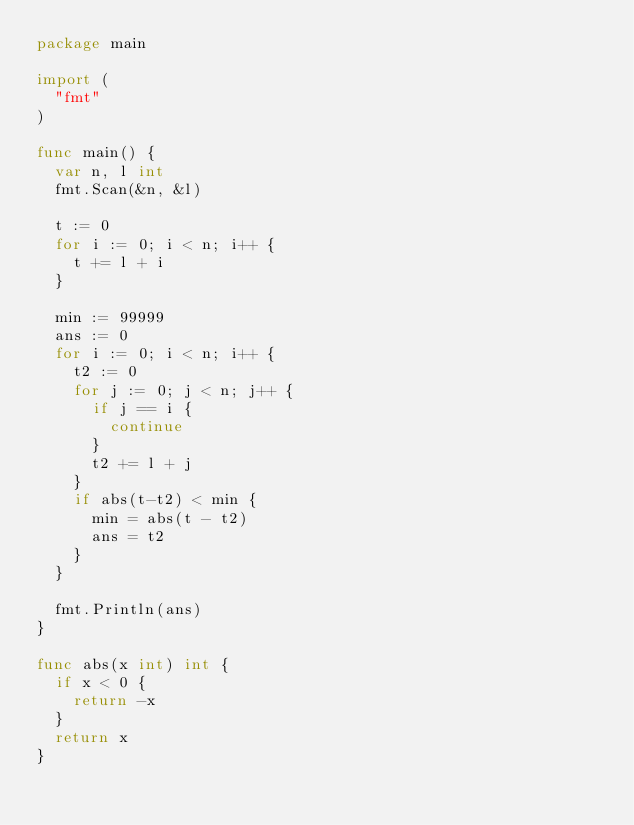Convert code to text. <code><loc_0><loc_0><loc_500><loc_500><_Go_>package main

import (
	"fmt"
)

func main() {
	var n, l int
	fmt.Scan(&n, &l)

	t := 0
	for i := 0; i < n; i++ {
		t += l + i
	}

	min := 99999
	ans := 0
	for i := 0; i < n; i++ {
		t2 := 0
		for j := 0; j < n; j++ {
			if j == i {
				continue
			}
			t2 += l + j
		}
		if abs(t-t2) < min {
			min = abs(t - t2)
			ans = t2
		}
	}

	fmt.Println(ans)
}

func abs(x int) int {
	if x < 0 {
		return -x
	}
	return x
}
</code> 